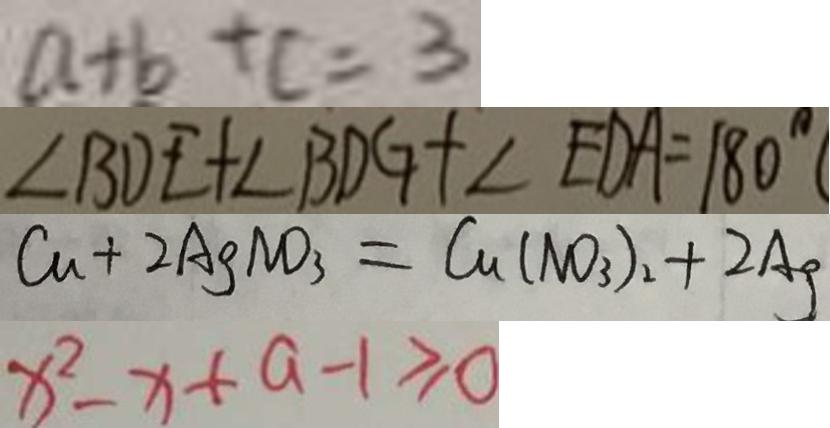Convert formula to latex. <formula><loc_0><loc_0><loc_500><loc_500>a + b + c = 3 
 \angle B D E + \angle B D G + \angle E O A = 1 8 0 ^ { \circ } 
 C u + 2 A g N O _ { 3 } = C u ( N O _ { 3 } ) _ { 2 } + 2 A g 
 x ^ { 2 } - x + a - 1 \geq 0</formula> 